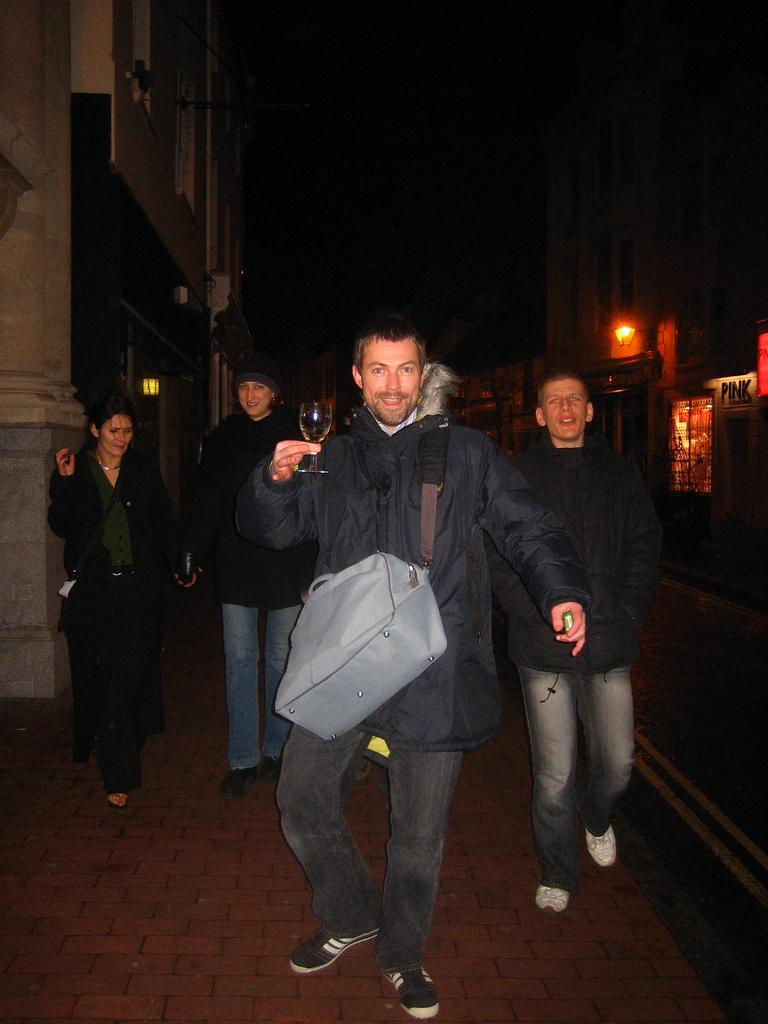What are the people in the image doing? People are standing in the image. Can you describe the person at the front? The person at the front is wearing a jacket and holding a bag and a glass. What can be seen in the background of the image? There are buildings visible in the background of the image. What type of brick is the person at the front holding in the image? There is no brick present in the image; the person at the front is holding a bag and a glass. 